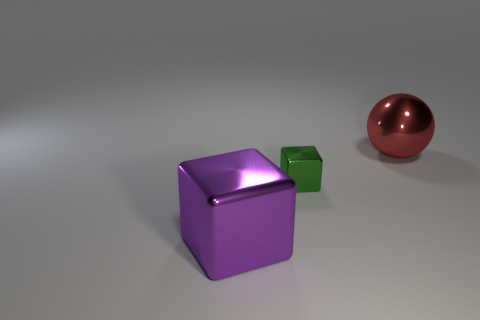Add 2 large red objects. How many objects exist? 5 Subtract 1 blocks. How many blocks are left? 1 Subtract all spheres. How many objects are left? 2 Subtract all cyan metal objects. Subtract all big things. How many objects are left? 1 Add 2 big things. How many big things are left? 4 Add 1 big yellow balls. How many big yellow balls exist? 1 Subtract 0 blue blocks. How many objects are left? 3 Subtract all blue balls. Subtract all red blocks. How many balls are left? 1 